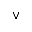<formula> <loc_0><loc_0><loc_500><loc_500>\lor</formula> 